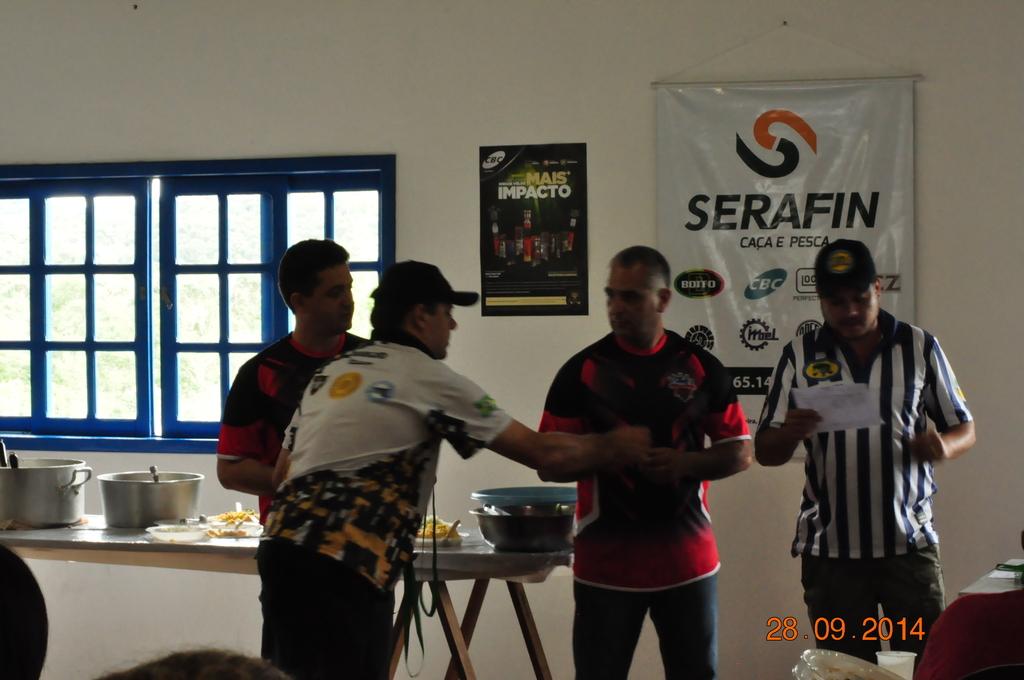What is the timestamp of the picture?
Offer a terse response. 28.09.2014. 